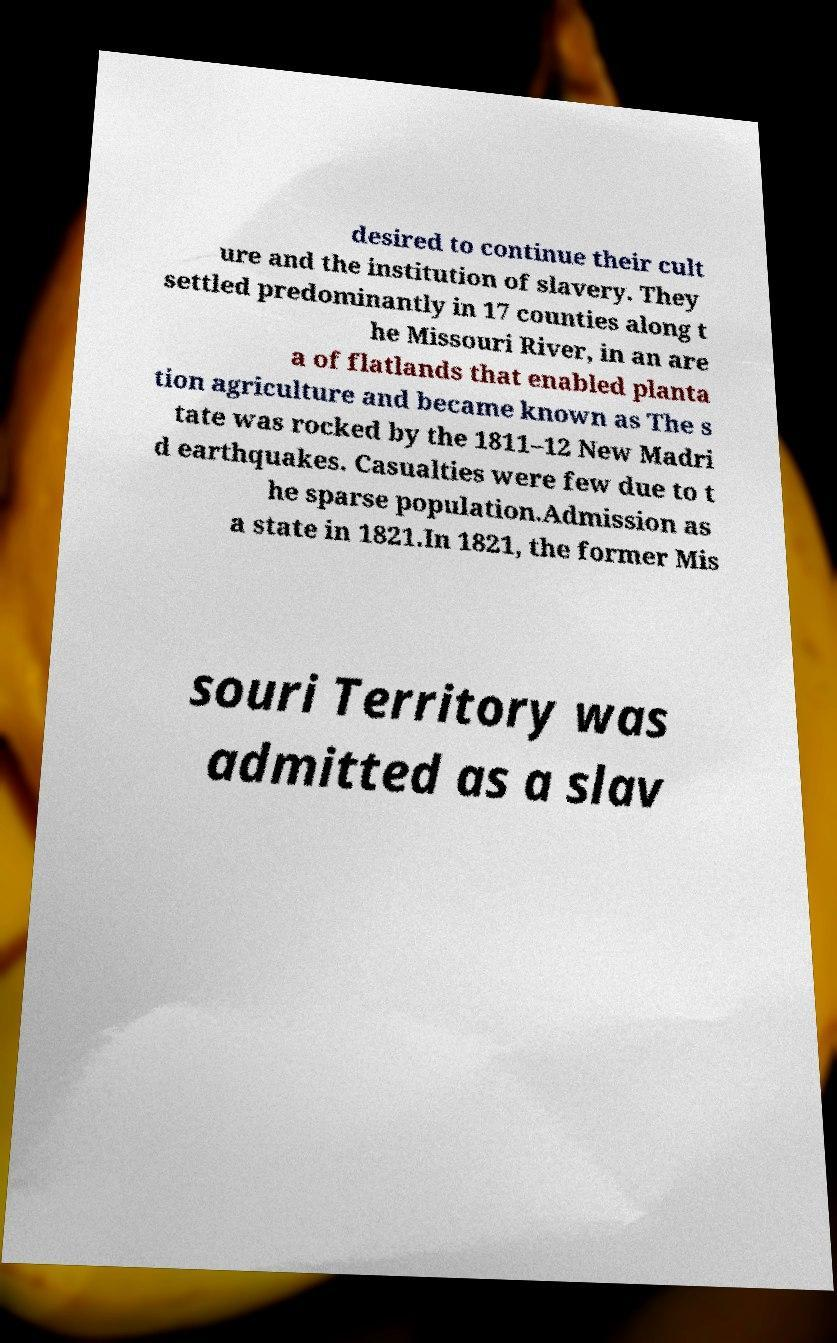There's text embedded in this image that I need extracted. Can you transcribe it verbatim? desired to continue their cult ure and the institution of slavery. They settled predominantly in 17 counties along t he Missouri River, in an are a of flatlands that enabled planta tion agriculture and became known as The s tate was rocked by the 1811–12 New Madri d earthquakes. Casualties were few due to t he sparse population.Admission as a state in 1821.In 1821, the former Mis souri Territory was admitted as a slav 